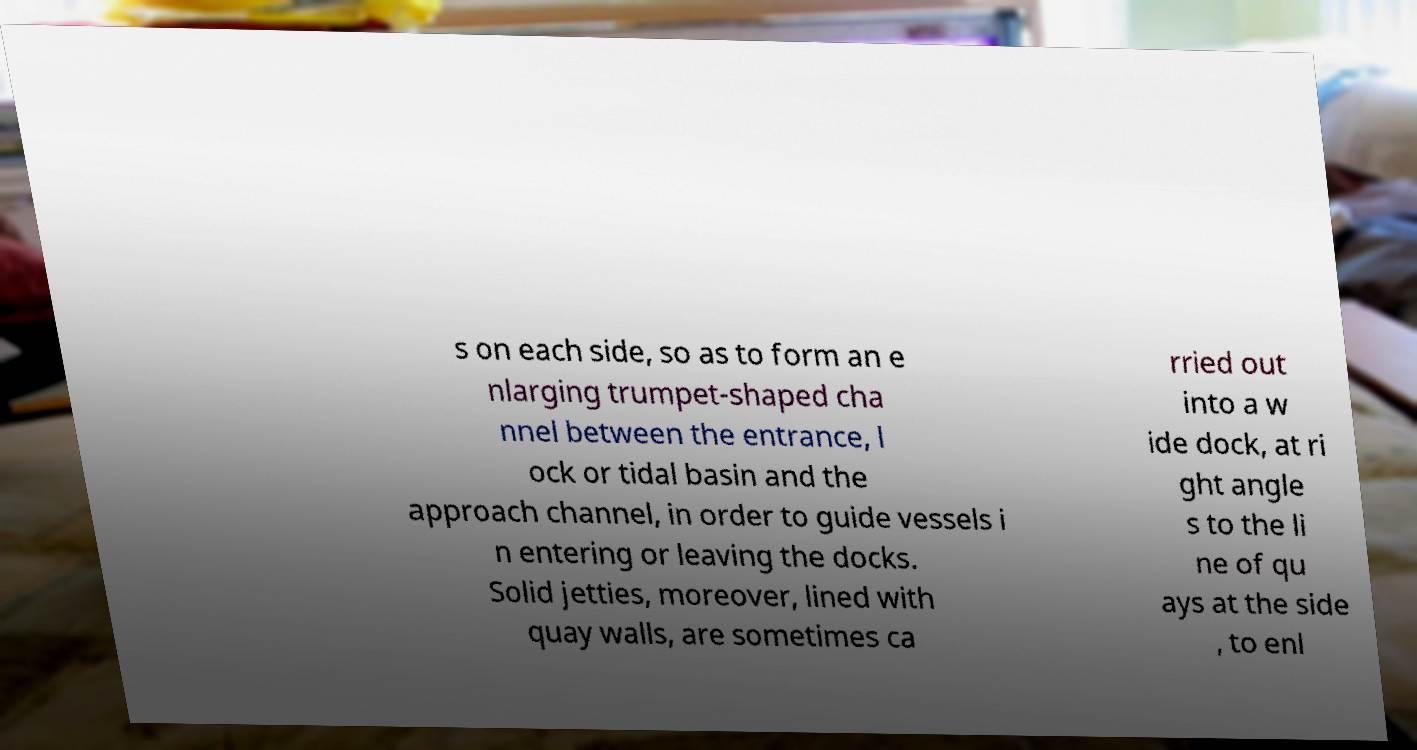Could you assist in decoding the text presented in this image and type it out clearly? s on each side, so as to form an e nlarging trumpet-shaped cha nnel between the entrance, l ock or tidal basin and the approach channel, in order to guide vessels i n entering or leaving the docks. Solid jetties, moreover, lined with quay walls, are sometimes ca rried out into a w ide dock, at ri ght angle s to the li ne of qu ays at the side , to enl 